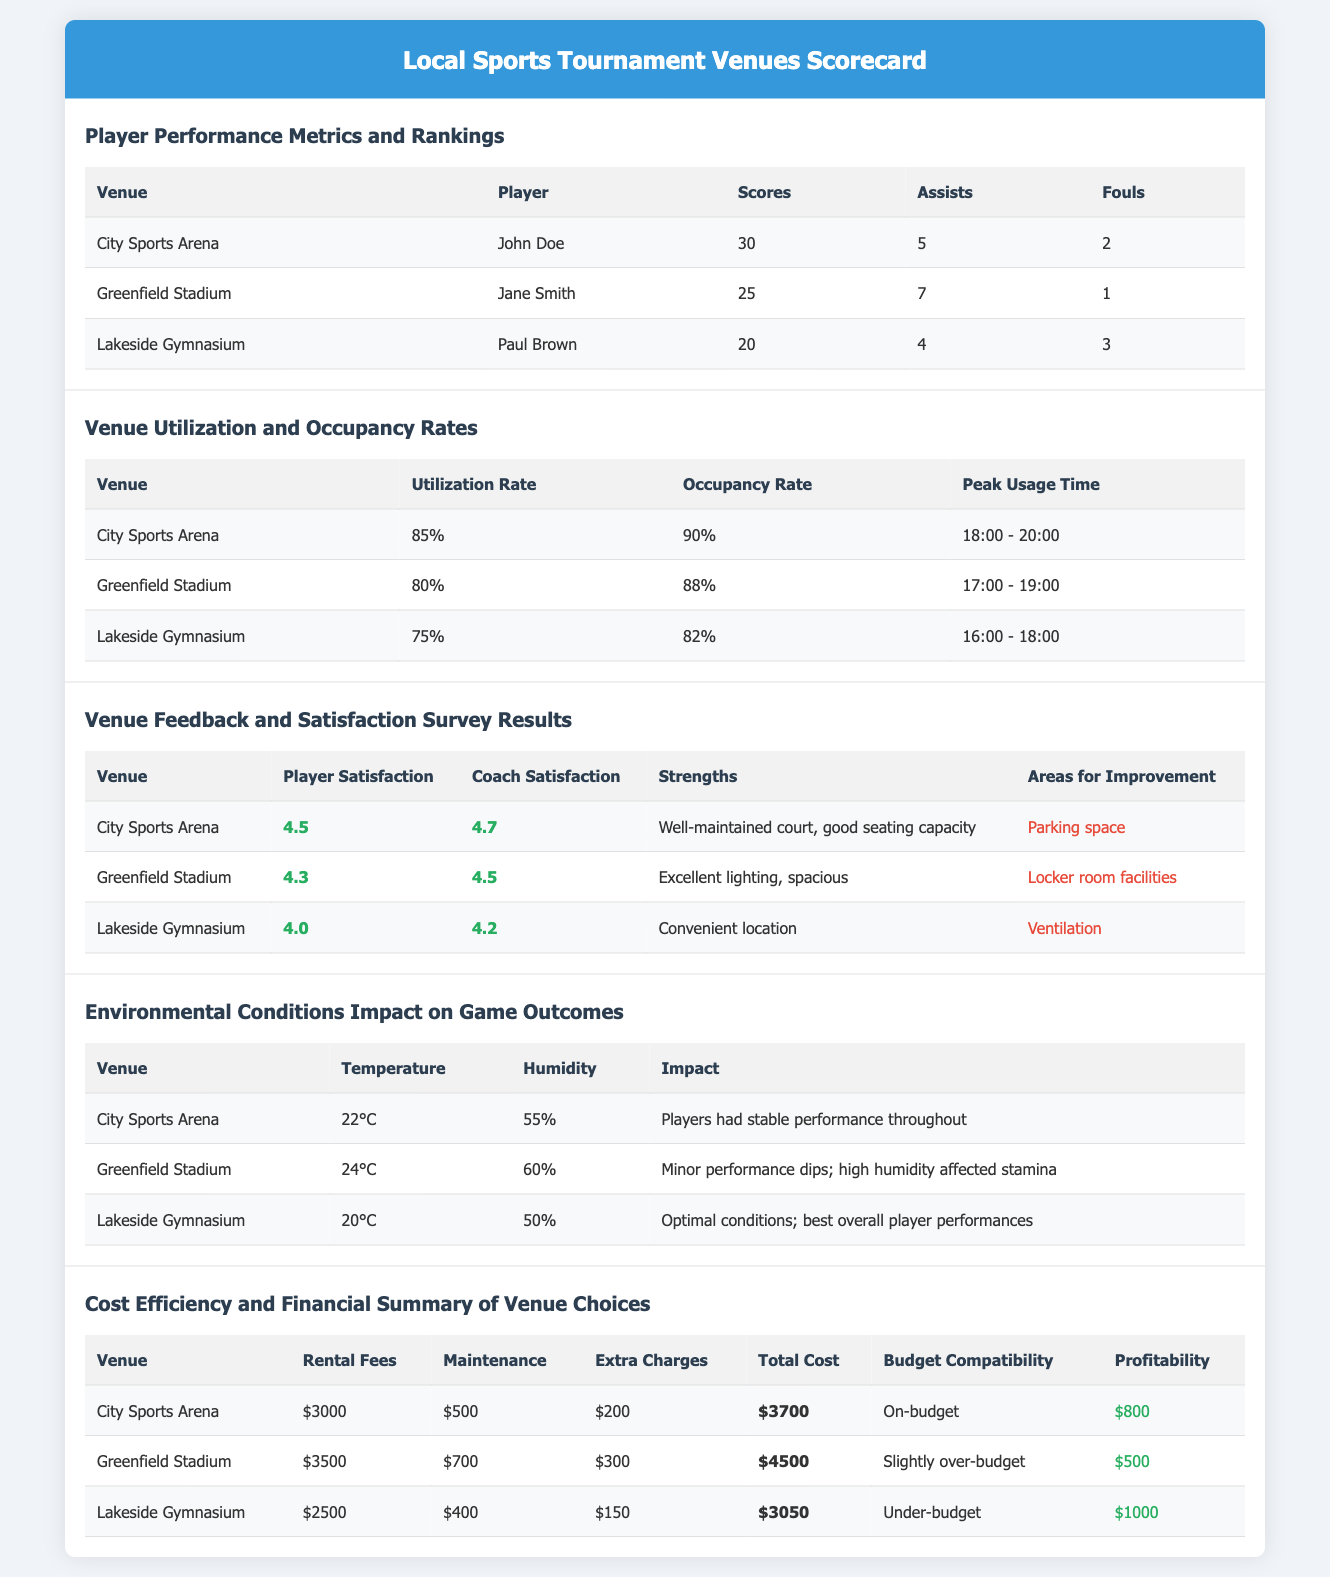What is the highest score recorded at the City Sports Arena? The highest score recorded at the City Sports Arena is 30 by John Doe.
Answer: 30 What feedback did players give for the Lakeside Gymnasium? Players rated their satisfaction at Lakeside Gymnasium as 4.0, indicating moderate satisfaction.
Answer: 4.0 Which venue had the highest occupancy rate? The City Sports Arena had the highest occupancy rate of 90%.
Answer: 90% What was the rental fee for Greenfield Stadium? The rental fee for Greenfield Stadium is $3500.
Answer: $3500 What environmental condition negatively impacted performance at Greenfield Stadium? High humidity affected stamina, causing minor performance dips at Greenfield Stadium.
Answer: High humidity Which venue is identified as under-budget? Lakeside Gymnasium is identified as under-budget with a total cost of $3050.
Answer: Under-budget What was the peak usage time for the City Sports Arena? The peak usage time for the City Sports Arena was from 18:00 to 20:00.
Answer: 18:00 - 20:00 What strength was highlighted for Greenfield Stadium? Excellent lighting was highlighted as a strength for Greenfield Stadium.
Answer: Excellent lighting Which player had the most assists at Lakeside Gymnasium? Paul Brown had 4 assists at Lakeside Gymnasium.
Answer: 4 assists 